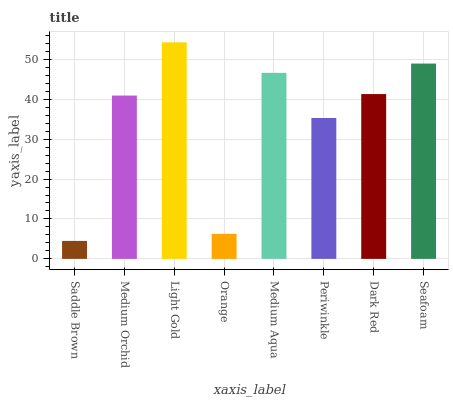Is Saddle Brown the minimum?
Answer yes or no. Yes. Is Light Gold the maximum?
Answer yes or no. Yes. Is Medium Orchid the minimum?
Answer yes or no. No. Is Medium Orchid the maximum?
Answer yes or no. No. Is Medium Orchid greater than Saddle Brown?
Answer yes or no. Yes. Is Saddle Brown less than Medium Orchid?
Answer yes or no. Yes. Is Saddle Brown greater than Medium Orchid?
Answer yes or no. No. Is Medium Orchid less than Saddle Brown?
Answer yes or no. No. Is Dark Red the high median?
Answer yes or no. Yes. Is Medium Orchid the low median?
Answer yes or no. Yes. Is Orange the high median?
Answer yes or no. No. Is Periwinkle the low median?
Answer yes or no. No. 